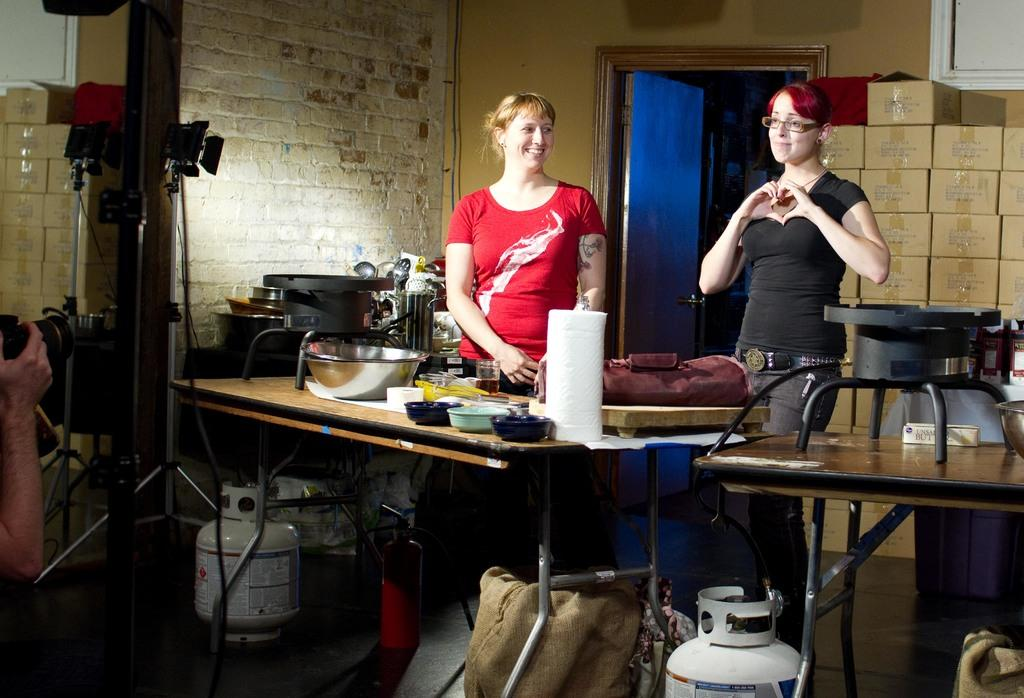How many women are present in the image? There are two women standing in the image. What objects can be seen on the table? There is a bowl, a glass, a stove, and a spoon stand on the table. What is located on the floor? There is an emergency gas cylinder on the floor. What is visible at the back side of the image? There is a door and a wall at the back side of the image. What type of bean is being cooked on the stove in the image? There is no bean visible in the image, and the stove is not being used for cooking. 